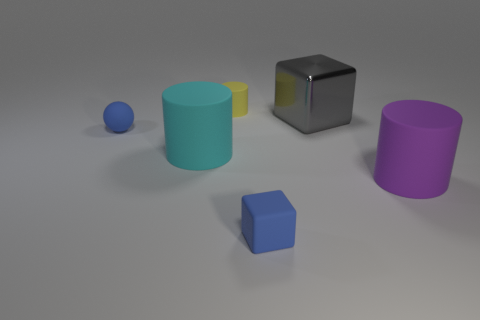Add 3 purple things. How many objects exist? 9 Subtract all blocks. How many objects are left? 4 Add 6 metal objects. How many metal objects are left? 7 Add 2 green metal cylinders. How many green metal cylinders exist? 2 Subtract 0 green cylinders. How many objects are left? 6 Subtract all blocks. Subtract all cyan objects. How many objects are left? 3 